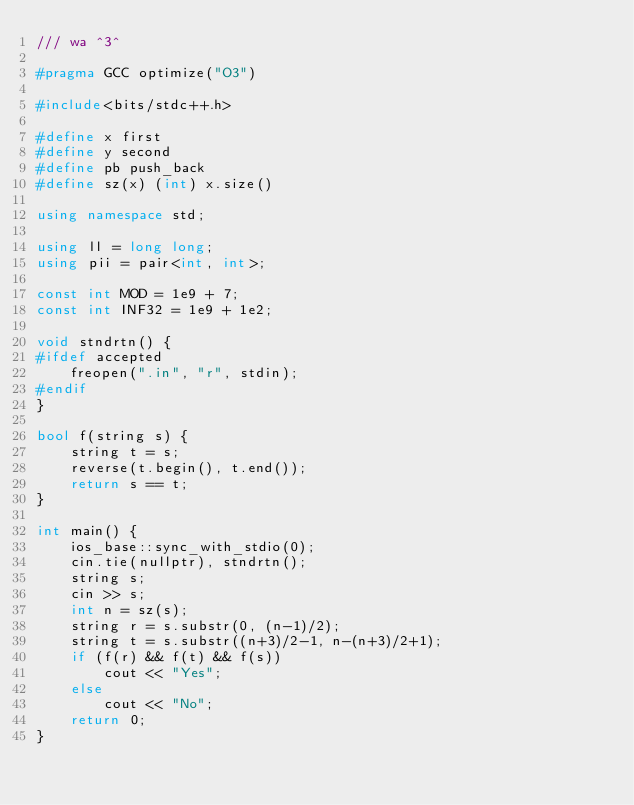Convert code to text. <code><loc_0><loc_0><loc_500><loc_500><_C++_>/// wa ^3^

#pragma GCC optimize("O3")

#include<bits/stdc++.h>
                           
#define x first
#define y second
#define pb push_back
#define sz(x) (int) x.size()
 
using namespace std;
 
using ll = long long;
using pii = pair<int, int>;                                   

const int MOD = 1e9 + 7;
const int INF32 = 1e9 + 1e2;

void stndrtn() {
#ifdef accepted
    freopen(".in", "r", stdin);
#endif        
}

bool f(string s) {
    string t = s;
    reverse(t.begin(), t.end());
    return s == t;
}

int main() {
    ios_base::sync_with_stdio(0);
    cin.tie(nullptr), stndrtn();
    string s;
    cin >> s;
    int n = sz(s);
    string r = s.substr(0, (n-1)/2);
    string t = s.substr((n+3)/2-1, n-(n+3)/2+1);
    if (f(r) && f(t) && f(s))
        cout << "Yes";
    else
        cout << "No";
    return 0;
}

</code> 